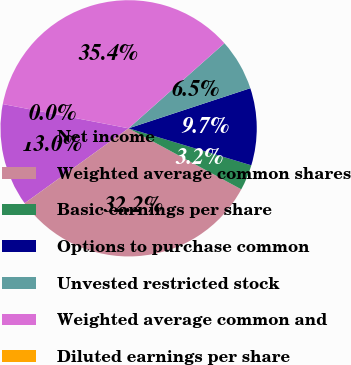Convert chart to OTSL. <chart><loc_0><loc_0><loc_500><loc_500><pie_chart><fcel>Net income<fcel>Weighted average common shares<fcel>Basic earnings per share<fcel>Options to purchase common<fcel>Unvested restricted stock<fcel>Weighted average common and<fcel>Diluted earnings per share<nl><fcel>12.97%<fcel>32.16%<fcel>3.24%<fcel>9.73%<fcel>6.49%<fcel>35.41%<fcel>0.0%<nl></chart> 